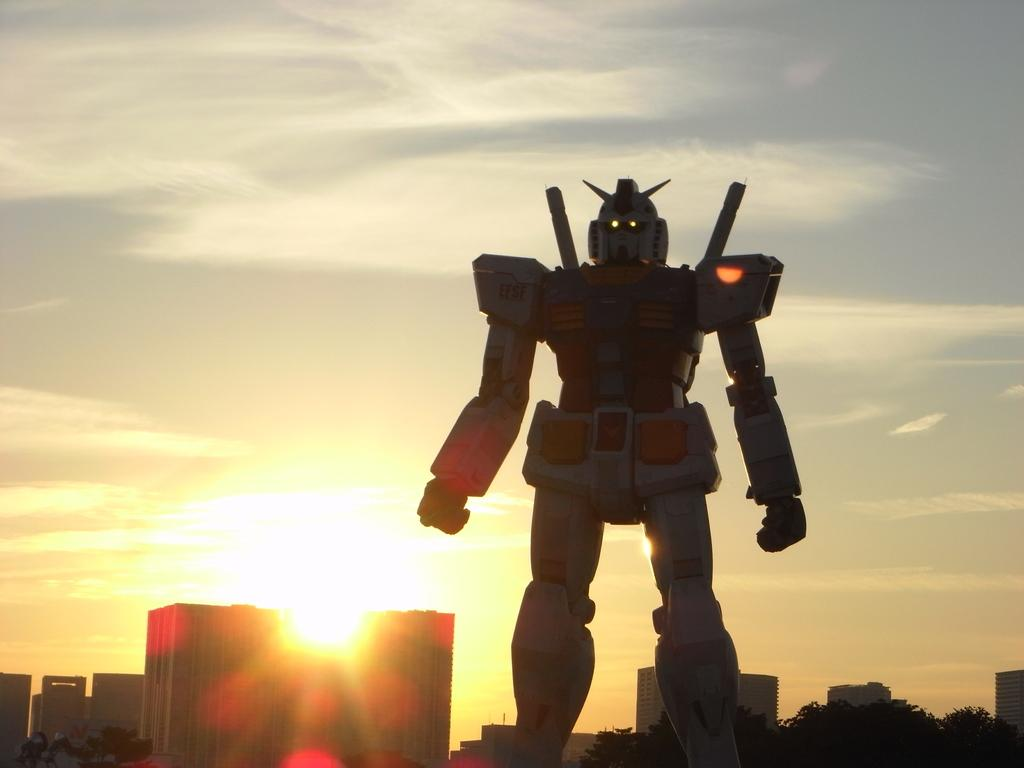What is the main subject in the center of the image? There is a robot in the center of the image. What type of structures can be seen in the image? There are buildings in the image. What type of vegetation is present in the image? There are trees in the image. What color is the poisonous mountain in the image? There is no mountain, poison, or color mentioned in the image. 